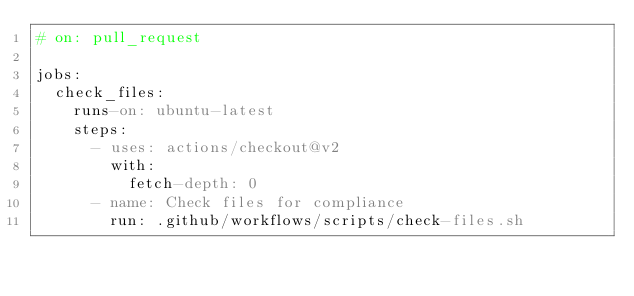Convert code to text. <code><loc_0><loc_0><loc_500><loc_500><_YAML_># on: pull_request

jobs:
  check_files:
    runs-on: ubuntu-latest
    steps:
      - uses: actions/checkout@v2
        with:
          fetch-depth: 0
      - name: Check files for compliance
        run: .github/workflows/scripts/check-files.sh
</code> 